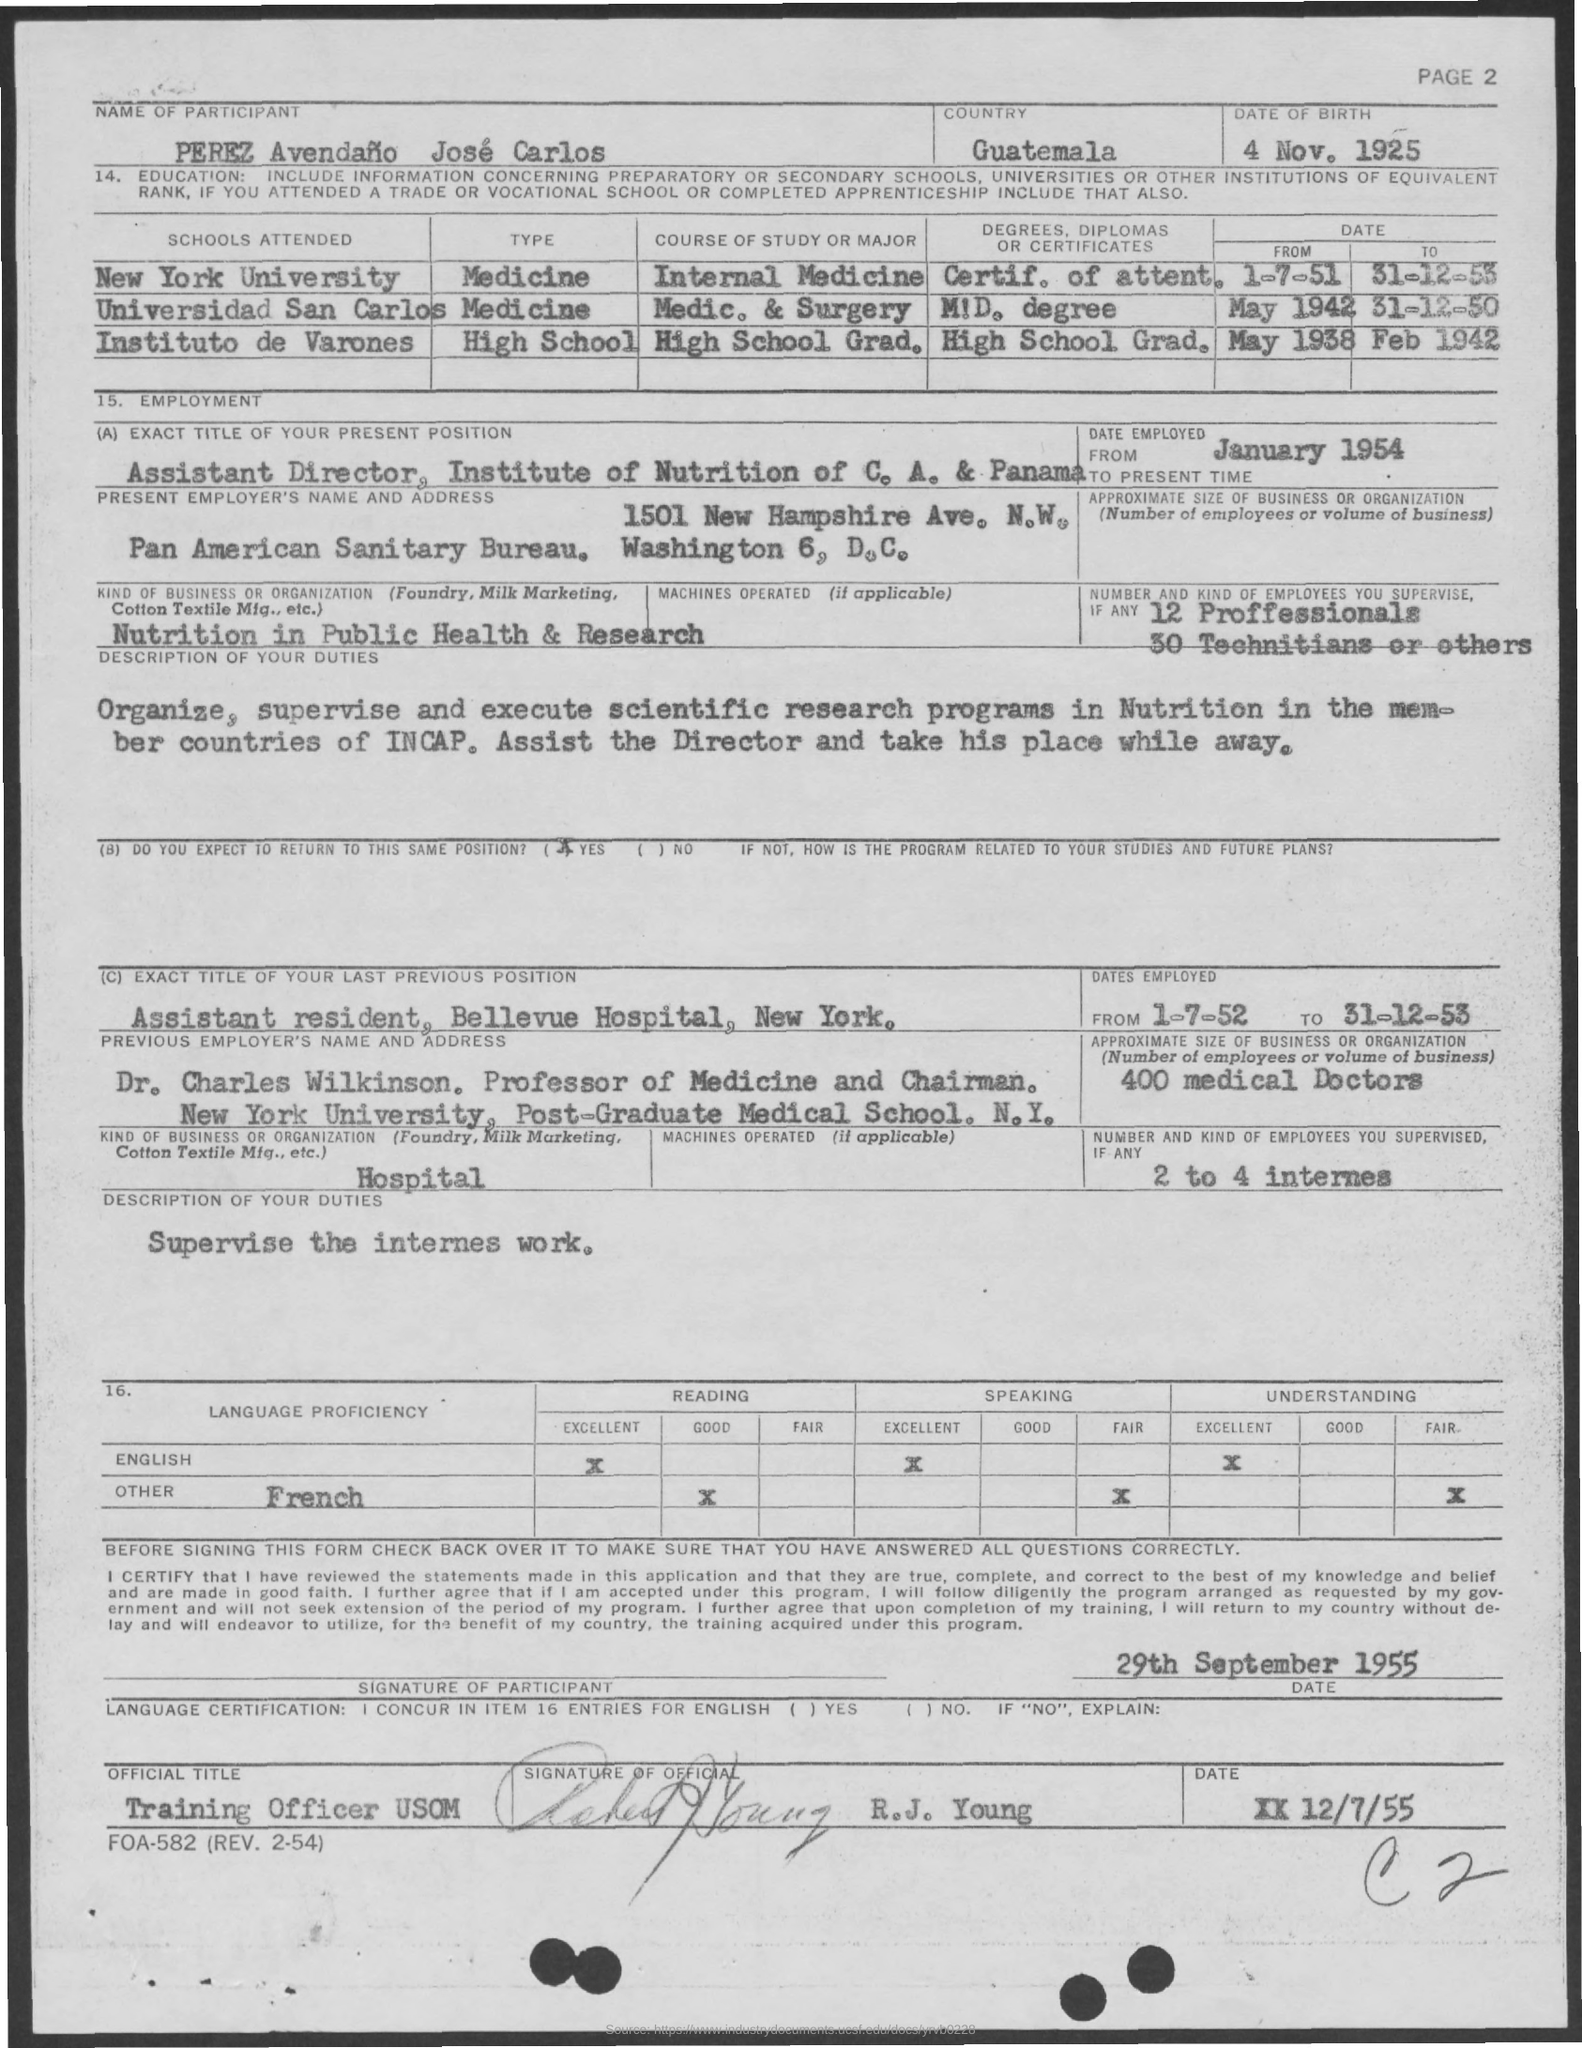What is the date of birth mentioned in the form ?
Keep it short and to the point. 4 NOV , 1925. What is the date employed as assistant director, in institute of nutrition of c.a. & panama ?
Provide a short and direct response. January 1954. What is the dates employed as assistant resident, in bellevue hospital , new york ?
Ensure brevity in your answer.  From 1-7-52 to 31-12-53. What are the number of professionals mentioned in the given form ?
Give a very brief answer. 12 Professionals. 